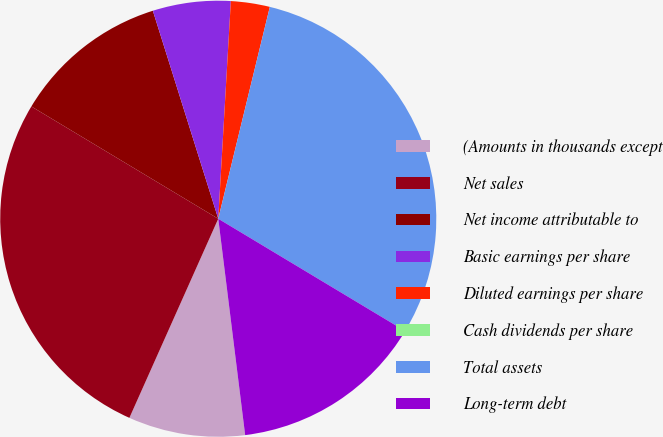Convert chart. <chart><loc_0><loc_0><loc_500><loc_500><pie_chart><fcel>(Amounts in thousands except<fcel>Net sales<fcel>Net income attributable to<fcel>Basic earnings per share<fcel>Diluted earnings per share<fcel>Cash dividends per share<fcel>Total assets<fcel>Long-term debt<nl><fcel>8.65%<fcel>26.93%<fcel>11.54%<fcel>5.77%<fcel>2.88%<fcel>0.0%<fcel>29.81%<fcel>14.42%<nl></chart> 